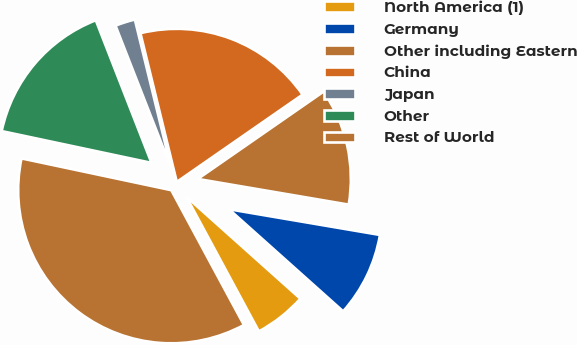<chart> <loc_0><loc_0><loc_500><loc_500><pie_chart><fcel>North America (1)<fcel>Germany<fcel>Other including Eastern<fcel>China<fcel>Japan<fcel>Other<fcel>Rest of World<nl><fcel>5.52%<fcel>8.93%<fcel>12.34%<fcel>19.16%<fcel>2.11%<fcel>15.75%<fcel>36.2%<nl></chart> 